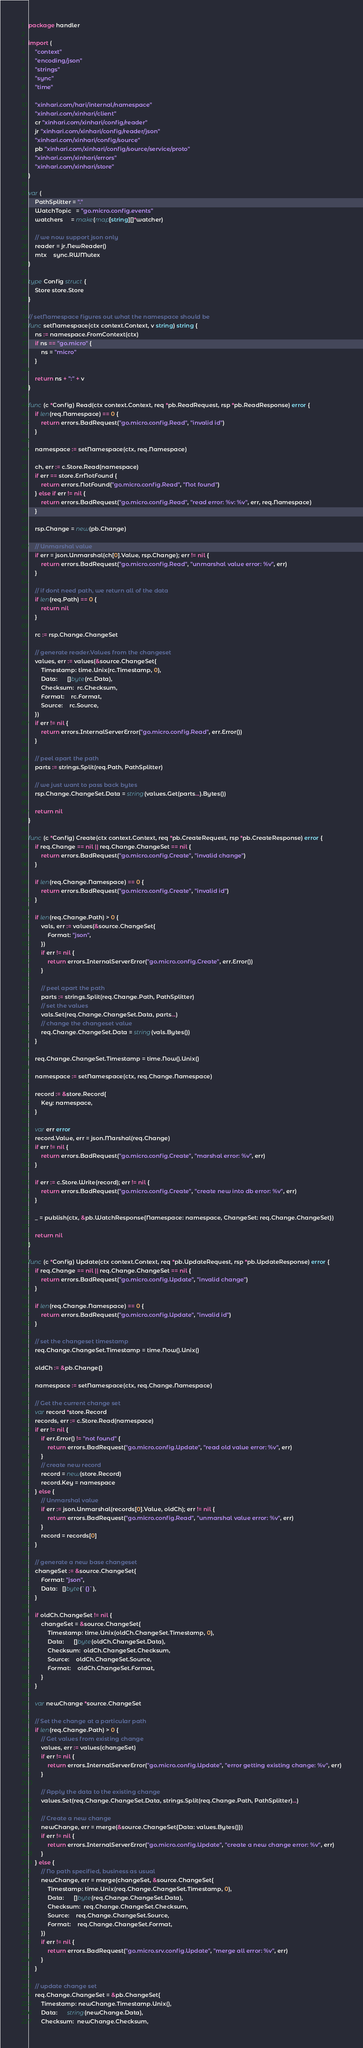<code> <loc_0><loc_0><loc_500><loc_500><_Go_>package handler

import (
	"context"
	"encoding/json"
	"strings"
	"sync"
	"time"

	"xinhari.com/hari/internal/namespace"
	"xinhari.com/xinhari/client"
	cr "xinhari.com/xinhari/config/reader"
	jr "xinhari.com/xinhari/config/reader/json"
	"xinhari.com/xinhari/config/source"
	pb "xinhari.com/xinhari/config/source/service/proto"
	"xinhari.com/xinhari/errors"
	"xinhari.com/xinhari/store"
)

var (
	PathSplitter = "."
	WatchTopic   = "go.micro.config.events"
	watchers     = make(map[string][]*watcher)

	// we now support json only
	reader = jr.NewReader()
	mtx    sync.RWMutex
)

type Config struct {
	Store store.Store
}

// setNamespace figures out what the namespace should be
func setNamespace(ctx context.Context, v string) string {
	ns := namespace.FromContext(ctx)
	if ns == "go.micro" {
		ns = "micro"
	}

	return ns + ":" + v
}

func (c *Config) Read(ctx context.Context, req *pb.ReadRequest, rsp *pb.ReadResponse) error {
	if len(req.Namespace) == 0 {
		return errors.BadRequest("go.micro.config.Read", "invalid id")
	}

	namespace := setNamespace(ctx, req.Namespace)

	ch, err := c.Store.Read(namespace)
	if err == store.ErrNotFound {
		return errors.NotFound("go.micro.config.Read", "Not found")
	} else if err != nil {
		return errors.BadRequest("go.micro.config.Read", "read error: %v: %v", err, req.Namespace)
	}

	rsp.Change = new(pb.Change)

	// Unmarshal value
	if err = json.Unmarshal(ch[0].Value, rsp.Change); err != nil {
		return errors.BadRequest("go.micro.config.Read", "unmarshal value error: %v", err)
	}

	// if dont need path, we return all of the data
	if len(req.Path) == 0 {
		return nil
	}

	rc := rsp.Change.ChangeSet

	// generate reader.Values from the changeset
	values, err := values(&source.ChangeSet{
		Timestamp: time.Unix(rc.Timestamp, 0),
		Data:      []byte(rc.Data),
		Checksum:  rc.Checksum,
		Format:    rc.Format,
		Source:    rc.Source,
	})
	if err != nil {
		return errors.InternalServerError("go.micro.config.Read", err.Error())
	}

	// peel apart the path
	parts := strings.Split(req.Path, PathSplitter)

	// we just want to pass back bytes
	rsp.Change.ChangeSet.Data = string(values.Get(parts...).Bytes())

	return nil
}

func (c *Config) Create(ctx context.Context, req *pb.CreateRequest, rsp *pb.CreateResponse) error {
	if req.Change == nil || req.Change.ChangeSet == nil {
		return errors.BadRequest("go.micro.config.Create", "invalid change")
	}

	if len(req.Change.Namespace) == 0 {
		return errors.BadRequest("go.micro.config.Create", "invalid id")
	}

	if len(req.Change.Path) > 0 {
		vals, err := values(&source.ChangeSet{
			Format: "json",
		})
		if err != nil {
			return errors.InternalServerError("go.micro.config.Create", err.Error())
		}

		// peel apart the path
		parts := strings.Split(req.Change.Path, PathSplitter)
		// set the values
		vals.Set(req.Change.ChangeSet.Data, parts...)
		// change the changeset value
		req.Change.ChangeSet.Data = string(vals.Bytes())
	}

	req.Change.ChangeSet.Timestamp = time.Now().Unix()

	namespace := setNamespace(ctx, req.Change.Namespace)

	record := &store.Record{
		Key: namespace,
	}

	var err error
	record.Value, err = json.Marshal(req.Change)
	if err != nil {
		return errors.BadRequest("go.micro.config.Create", "marshal error: %v", err)
	}

	if err := c.Store.Write(record); err != nil {
		return errors.BadRequest("go.micro.config.Create", "create new into db error: %v", err)
	}

	_ = publish(ctx, &pb.WatchResponse{Namespace: namespace, ChangeSet: req.Change.ChangeSet})

	return nil
}

func (c *Config) Update(ctx context.Context, req *pb.UpdateRequest, rsp *pb.UpdateResponse) error {
	if req.Change == nil || req.Change.ChangeSet == nil {
		return errors.BadRequest("go.micro.config.Update", "invalid change")
	}

	if len(req.Change.Namespace) == 0 {
		return errors.BadRequest("go.micro.config.Update", "invalid id")
	}

	// set the changeset timestamp
	req.Change.ChangeSet.Timestamp = time.Now().Unix()

	oldCh := &pb.Change{}

	namespace := setNamespace(ctx, req.Change.Namespace)

	// Get the current change set
	var record *store.Record
	records, err := c.Store.Read(namespace)
	if err != nil {
		if err.Error() != "not found" {
			return errors.BadRequest("go.micro.config.Update", "read old value error: %v", err)
		}
		// create new record
		record = new(store.Record)
		record.Key = namespace
	} else {
		// Unmarshal value
		if err := json.Unmarshal(records[0].Value, oldCh); err != nil {
			return errors.BadRequest("go.micro.config.Read", "unmarshal value error: %v", err)
		}
		record = records[0]
	}

	// generate a new base changeset
	changeSet := &source.ChangeSet{
		Format: "json",
		Data:   []byte(`{}`),
	}

	if oldCh.ChangeSet != nil {
		changeSet = &source.ChangeSet{
			Timestamp: time.Unix(oldCh.ChangeSet.Timestamp, 0),
			Data:      []byte(oldCh.ChangeSet.Data),
			Checksum:  oldCh.ChangeSet.Checksum,
			Source:    oldCh.ChangeSet.Source,
			Format:    oldCh.ChangeSet.Format,
		}
	}

	var newChange *source.ChangeSet

	// Set the change at a particular path
	if len(req.Change.Path) > 0 {
		// Get values from existing change
		values, err := values(changeSet)
		if err != nil {
			return errors.InternalServerError("go.micro.config.Update", "error getting existing change: %v", err)
		}

		// Apply the data to the existing change
		values.Set(req.Change.ChangeSet.Data, strings.Split(req.Change.Path, PathSplitter)...)

		// Create a new change
		newChange, err = merge(&source.ChangeSet{Data: values.Bytes()})
		if err != nil {
			return errors.InternalServerError("go.micro.config.Update", "create a new change error: %v", err)
		}
	} else {
		// No path specified, business as usual
		newChange, err = merge(changeSet, &source.ChangeSet{
			Timestamp: time.Unix(req.Change.ChangeSet.Timestamp, 0),
			Data:      []byte(req.Change.ChangeSet.Data),
			Checksum:  req.Change.ChangeSet.Checksum,
			Source:    req.Change.ChangeSet.Source,
			Format:    req.Change.ChangeSet.Format,
		})
		if err != nil {
			return errors.BadRequest("go.micro.srv.config.Update", "merge all error: %v", err)
		}
	}

	// update change set
	req.Change.ChangeSet = &pb.ChangeSet{
		Timestamp: newChange.Timestamp.Unix(),
		Data:      string(newChange.Data),
		Checksum:  newChange.Checksum,</code> 